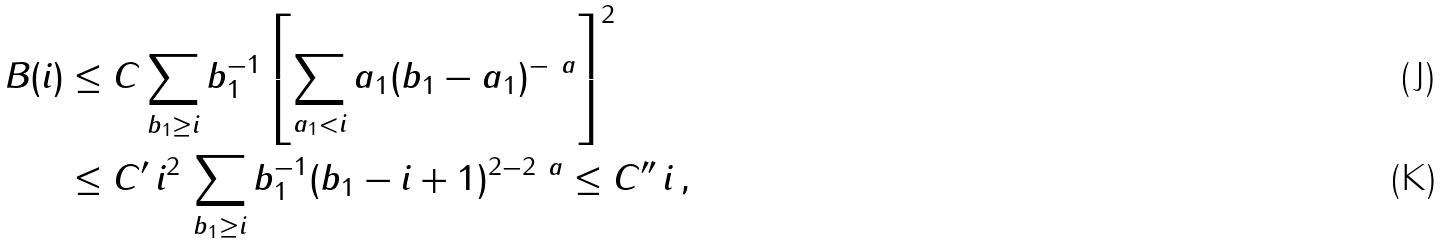<formula> <loc_0><loc_0><loc_500><loc_500>B ( i ) & \leq C \sum _ { b _ { 1 } \geq i } b _ { 1 } ^ { - 1 } \left [ \sum _ { a _ { 1 } < i } a _ { 1 } ( b _ { 1 } - a _ { 1 } ) ^ { - \ a } \right ] ^ { 2 } \\ & \leq C ^ { \prime } \, i ^ { 2 } \, \sum _ { b _ { 1 } \geq i } b _ { 1 } ^ { - 1 } ( b _ { 1 } - i + 1 ) ^ { 2 - 2 \ a } \leq C ^ { \prime \prime } \, i \, ,</formula> 